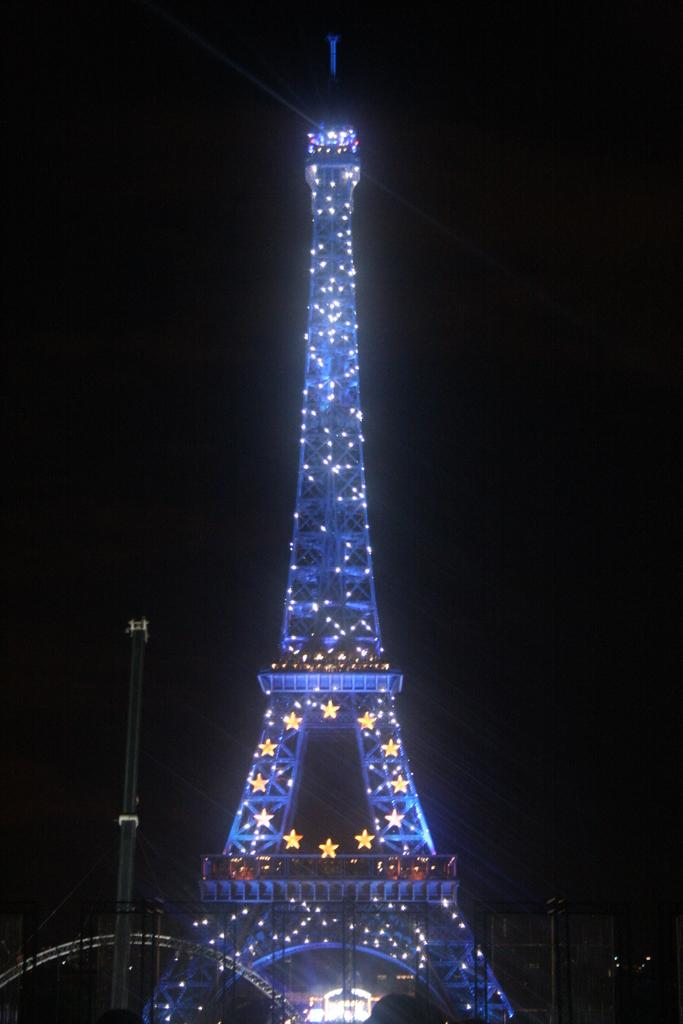What is the main structure in the middle of the image? There is a tower with lights in the middle of the image. What can be seen on the left side of the image? There is a pole on the left side of the image. What color is the background of the image? The background of the image appears to be black. How many muscles are visible in the image? There are no muscles visible in the image; it features a tower with lights and a pole. What type of place is depicted in the image? The image does not depict a specific place; it focuses on the tower, pole, and black background. 